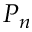Convert formula to latex. <formula><loc_0><loc_0><loc_500><loc_500>P _ { n }</formula> 